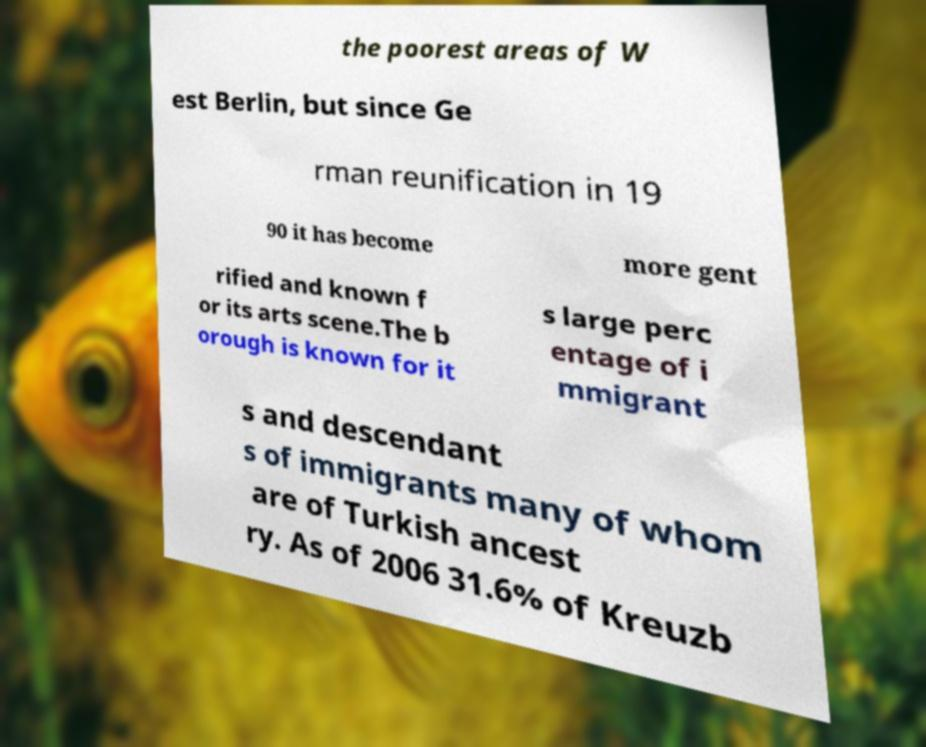Could you extract and type out the text from this image? the poorest areas of W est Berlin, but since Ge rman reunification in 19 90 it has become more gent rified and known f or its arts scene.The b orough is known for it s large perc entage of i mmigrant s and descendant s of immigrants many of whom are of Turkish ancest ry. As of 2006 31.6% of Kreuzb 